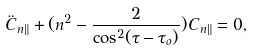Convert formula to latex. <formula><loc_0><loc_0><loc_500><loc_500>\ddot { C } _ { n \| } + ( n ^ { 2 } - \frac { 2 } { \cos ^ { 2 } ( \tau - \tau _ { o } ) } ) C _ { n \| } = 0 ,</formula> 